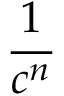<formula> <loc_0><loc_0><loc_500><loc_500>\frac { 1 } { c ^ { n } }</formula> 